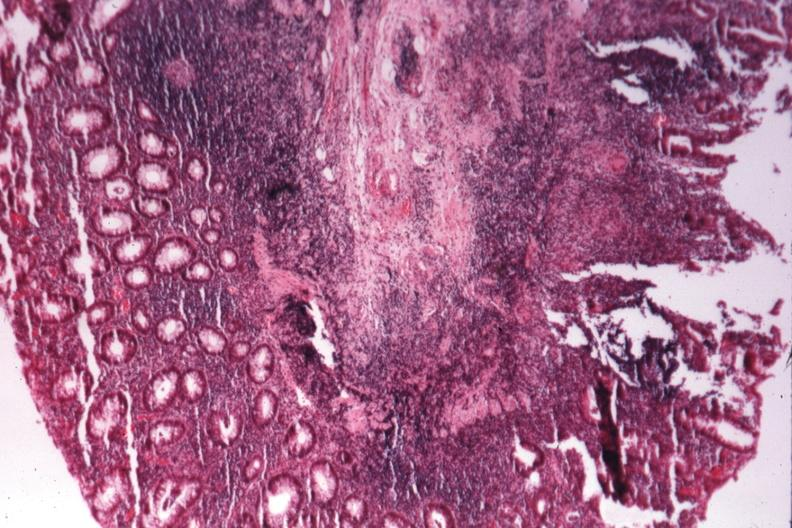s artery present?
Answer the question using a single word or phrase. No 